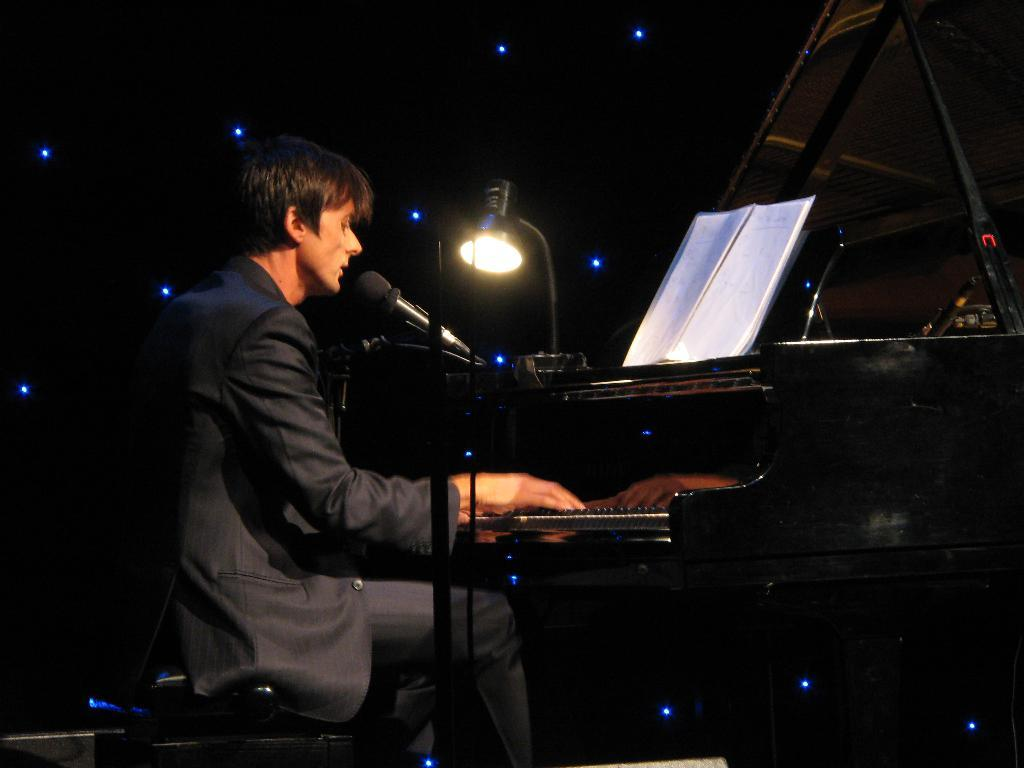What is the person in the image doing? The person is singing and playing a piano. What is the person wearing in the image? The person is wearing a black coat. What is the person sitting on in the image? The person is sitting on a stool. What objects are present in the image related to the person's performance? There is a mic with a mic stand and a book on the piano. What additional object is present on the piano? There is a lamp on the piano. Are there any giants visible in the image? No, there are no giants present in the image. What type of cable is connected to the piano in the image? There is no cable connected to the piano in the image. 